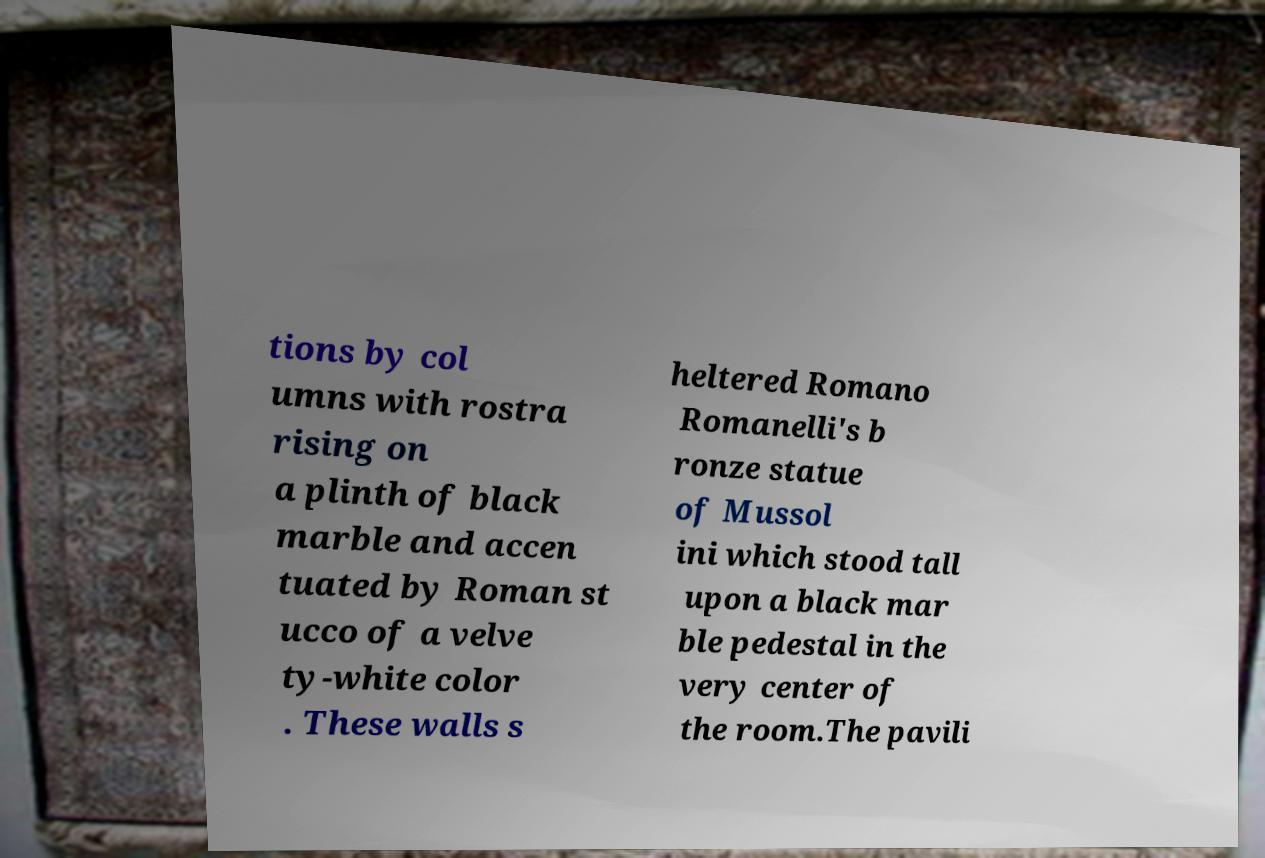Please read and relay the text visible in this image. What does it say? tions by col umns with rostra rising on a plinth of black marble and accen tuated by Roman st ucco of a velve ty-white color . These walls s heltered Romano Romanelli's b ronze statue of Mussol ini which stood tall upon a black mar ble pedestal in the very center of the room.The pavili 